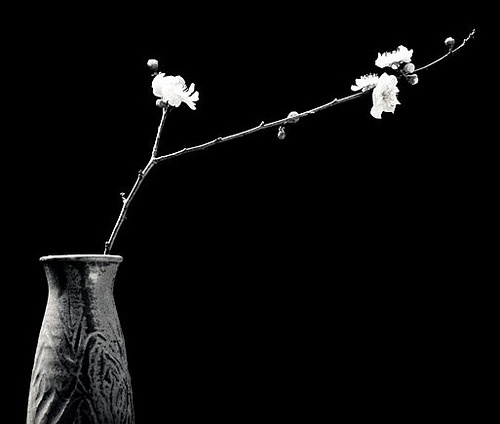Describe the objects in this image and their specific colors. I can see potted plant in black, gray, white, and darkgray tones and vase in black, gray, darkgray, and lightgray tones in this image. 